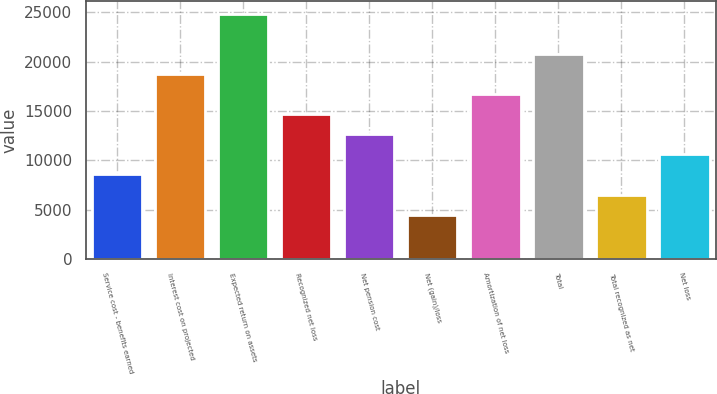Convert chart. <chart><loc_0><loc_0><loc_500><loc_500><bar_chart><fcel>Service cost - benefits earned<fcel>Interest cost on projected<fcel>Expected return on assets<fcel>Recognized net loss<fcel>Net pension cost<fcel>Net (gain)/loss<fcel>Amortization of net loss<fcel>Total<fcel>Total recognized as net<fcel>Net loss<nl><fcel>8567.8<fcel>18767.3<fcel>24887<fcel>14687.5<fcel>12647.6<fcel>4488<fcel>16727.4<fcel>20807.2<fcel>6527.9<fcel>10607.7<nl></chart> 